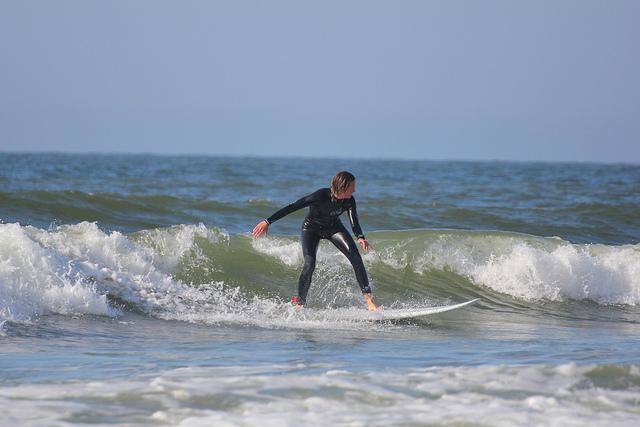What color is the board on the wave?
Short answer required. White. Is the surfer balding?
Keep it brief. No. What is the person standing on?
Be succinct. Surfboard. Is the man going to fall?
Give a very brief answer. No. 